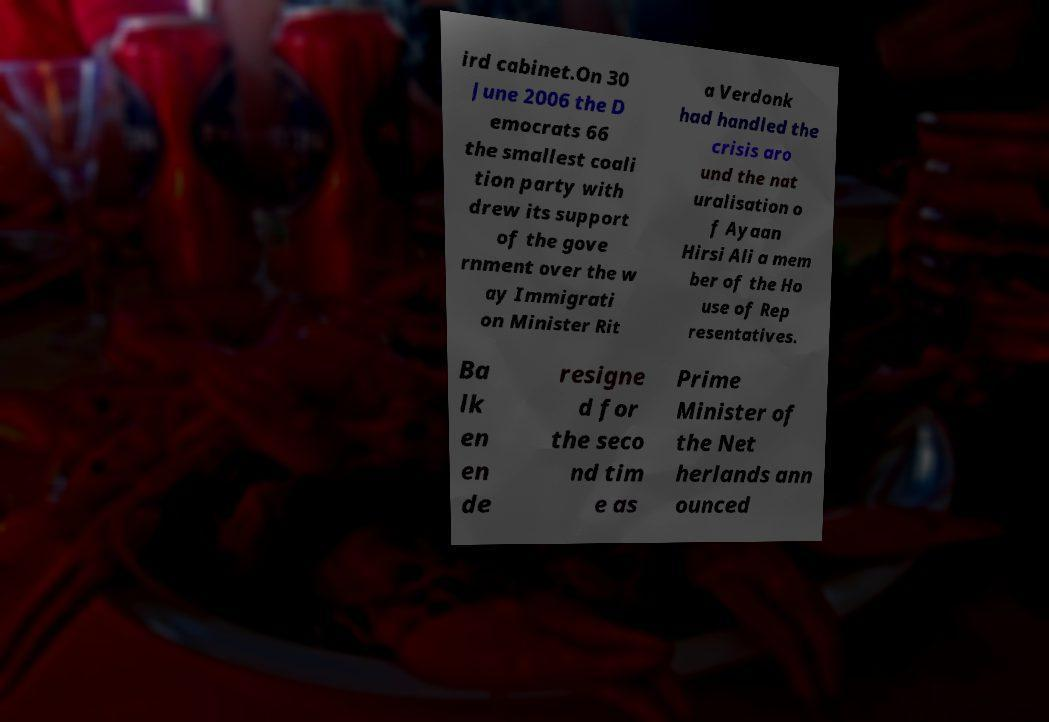There's text embedded in this image that I need extracted. Can you transcribe it verbatim? ird cabinet.On 30 June 2006 the D emocrats 66 the smallest coali tion party with drew its support of the gove rnment over the w ay Immigrati on Minister Rit a Verdonk had handled the crisis aro und the nat uralisation o f Ayaan Hirsi Ali a mem ber of the Ho use of Rep resentatives. Ba lk en en de resigne d for the seco nd tim e as Prime Minister of the Net herlands ann ounced 